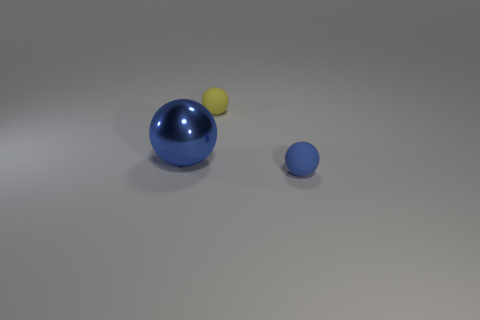Is there any other thing that is made of the same material as the large ball?
Your answer should be very brief. No. What number of other objects are there of the same shape as the small blue thing?
Your answer should be compact. 2. There is a tiny sphere that is to the left of the small rubber sphere that is on the right side of the small yellow rubber ball; what number of large blue things are in front of it?
Offer a very short reply. 1. What number of small blue things are the same shape as the yellow rubber object?
Give a very brief answer. 1. Do the tiny thing right of the yellow rubber thing and the big thing have the same color?
Offer a terse response. Yes. The big object that is in front of the tiny yellow thing that is right of the metal thing that is in front of the tiny yellow rubber sphere is what shape?
Keep it short and to the point. Sphere. There is a yellow matte sphere; does it have the same size as the rubber object in front of the blue shiny object?
Provide a succinct answer. Yes. Are there any yellow spheres of the same size as the blue metallic sphere?
Give a very brief answer. No. How many other things are the same material as the yellow sphere?
Offer a very short reply. 1. What color is the object that is both left of the small blue sphere and in front of the yellow matte thing?
Your response must be concise. Blue. 